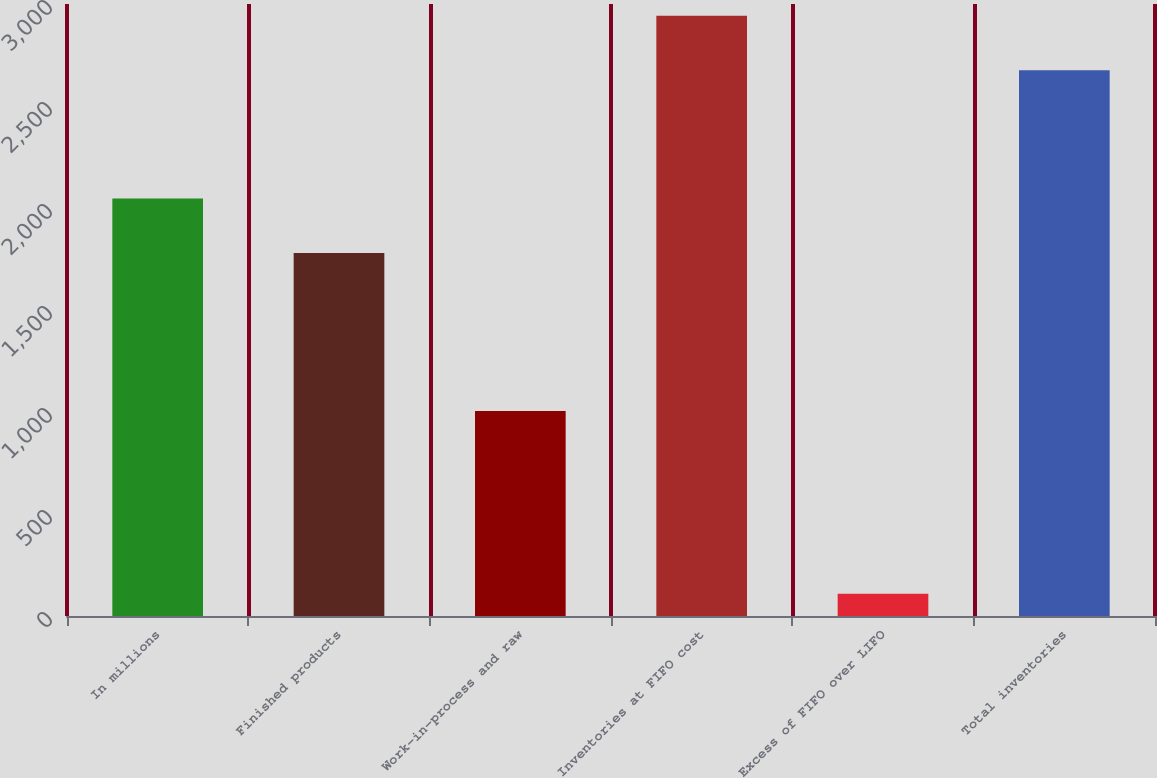Convert chart to OTSL. <chart><loc_0><loc_0><loc_500><loc_500><bar_chart><fcel>In millions<fcel>Finished products<fcel>Work-in-process and raw<fcel>Inventories at FIFO cost<fcel>Excess of FIFO over LIFO<fcel>Total inventories<nl><fcel>2046.5<fcel>1779<fcel>1005<fcel>2942.5<fcel>109<fcel>2675<nl></chart> 